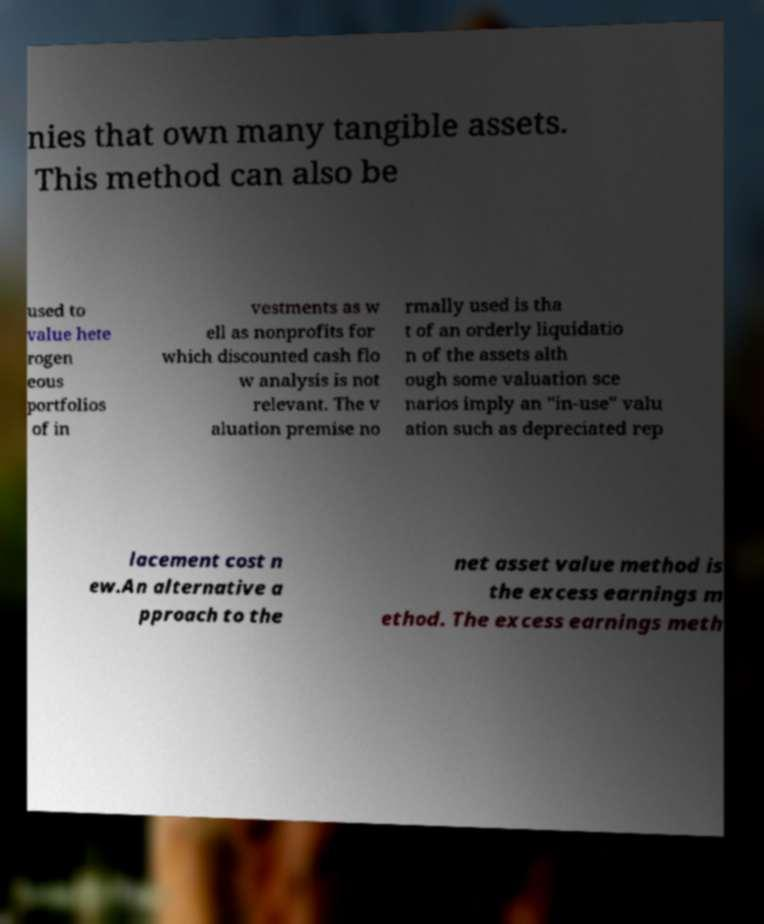Can you accurately transcribe the text from the provided image for me? nies that own many tangible assets. This method can also be used to value hete rogen eous portfolios of in vestments as w ell as nonprofits for which discounted cash flo w analysis is not relevant. The v aluation premise no rmally used is tha t of an orderly liquidatio n of the assets alth ough some valuation sce narios imply an "in-use" valu ation such as depreciated rep lacement cost n ew.An alternative a pproach to the net asset value method is the excess earnings m ethod. The excess earnings meth 